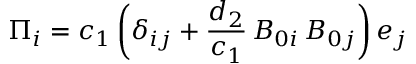<formula> <loc_0><loc_0><loc_500><loc_500>{ \Pi _ { i } } = { c _ { 1 } } \left ( { { \delta _ { i j } } + \frac { { { d _ { 2 } } } } { { { c _ { 1 } } } } \, { B _ { 0 i } } \, { B _ { 0 j } } } \right ) { e _ { j } }</formula> 